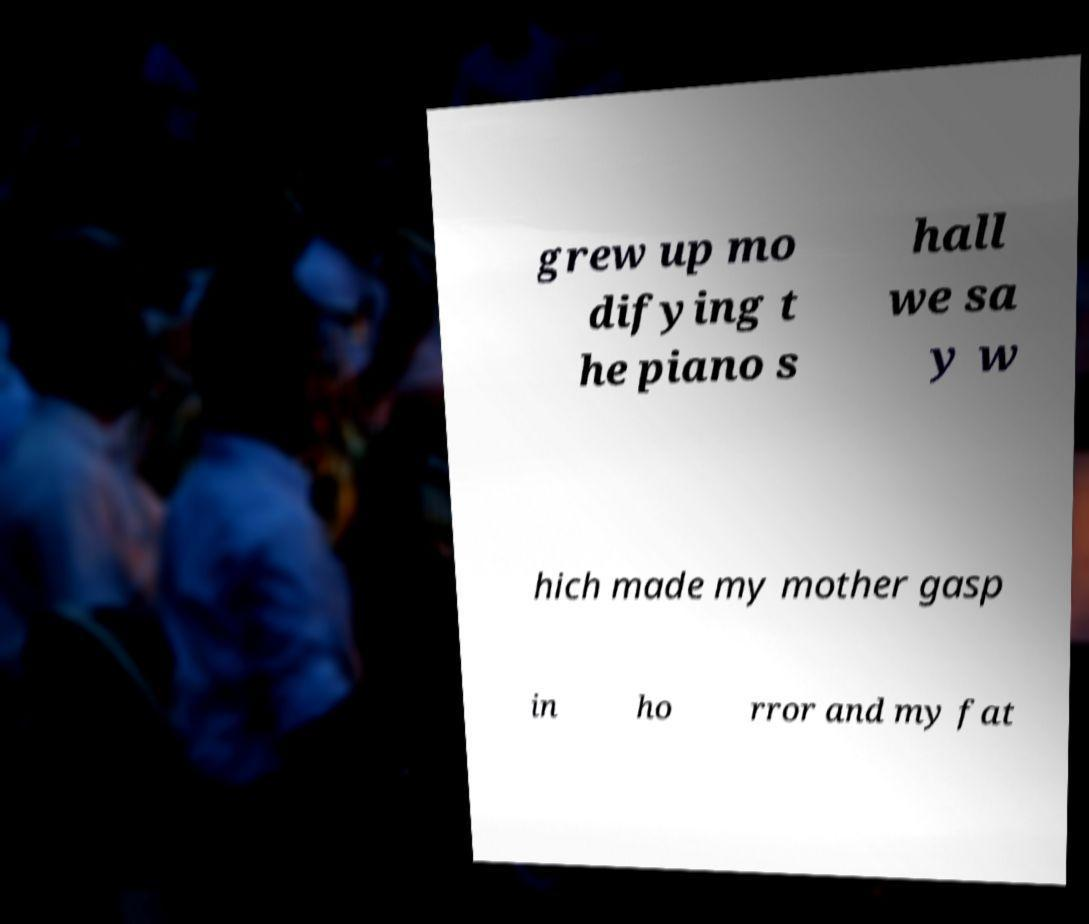What messages or text are displayed in this image? I need them in a readable, typed format. grew up mo difying t he piano s hall we sa y w hich made my mother gasp in ho rror and my fat 